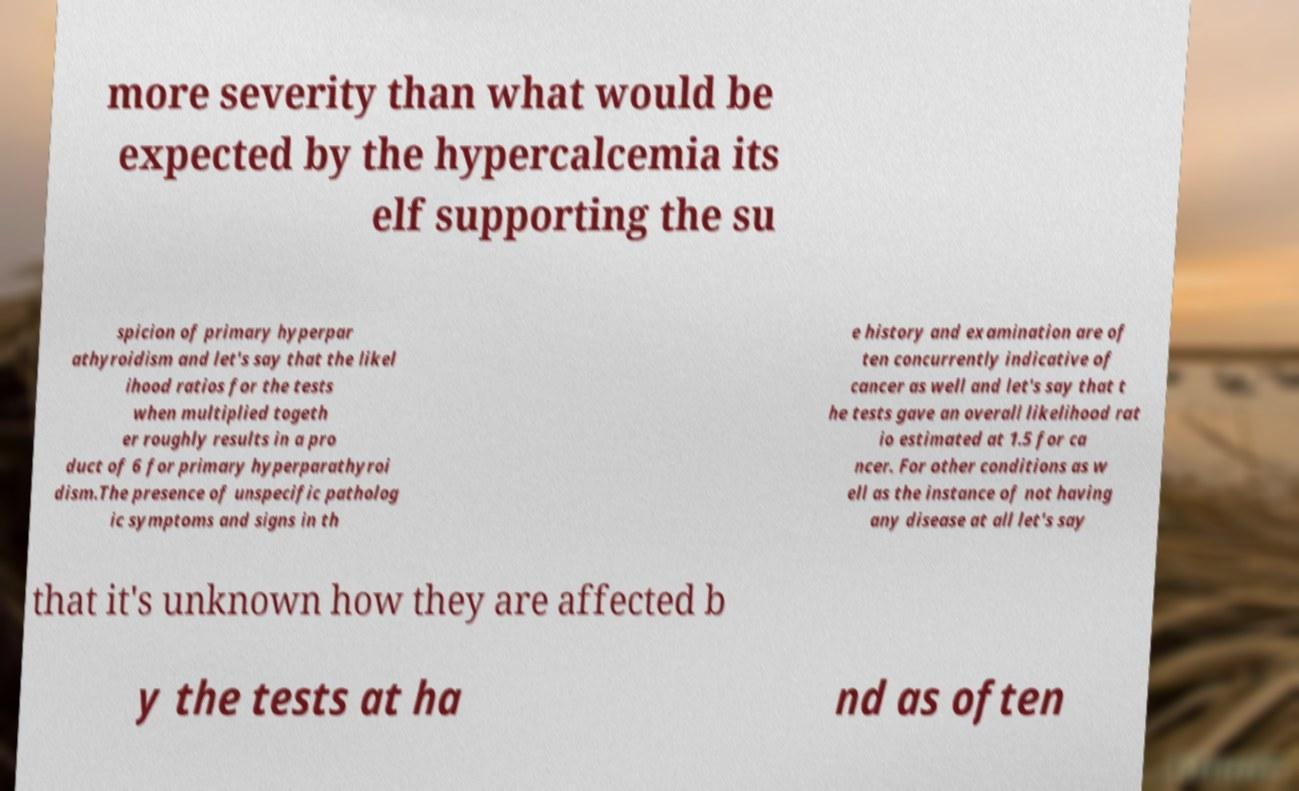Can you read and provide the text displayed in the image?This photo seems to have some interesting text. Can you extract and type it out for me? more severity than what would be expected by the hypercalcemia its elf supporting the su spicion of primary hyperpar athyroidism and let's say that the likel ihood ratios for the tests when multiplied togeth er roughly results in a pro duct of 6 for primary hyperparathyroi dism.The presence of unspecific patholog ic symptoms and signs in th e history and examination are of ten concurrently indicative of cancer as well and let's say that t he tests gave an overall likelihood rat io estimated at 1.5 for ca ncer. For other conditions as w ell as the instance of not having any disease at all let's say that it's unknown how they are affected b y the tests at ha nd as often 